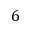<formula> <loc_0><loc_0><loc_500><loc_500>6</formula> 